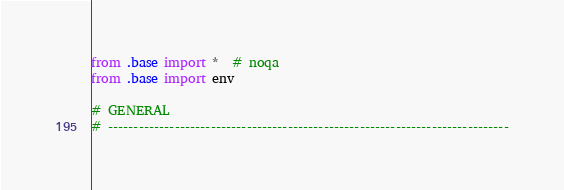<code> <loc_0><loc_0><loc_500><loc_500><_Python_>from .base import *  # noqa
from .base import env

# GENERAL
# ------------------------------------------------------------------------------</code> 